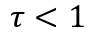Convert formula to latex. <formula><loc_0><loc_0><loc_500><loc_500>\tau < 1</formula> 